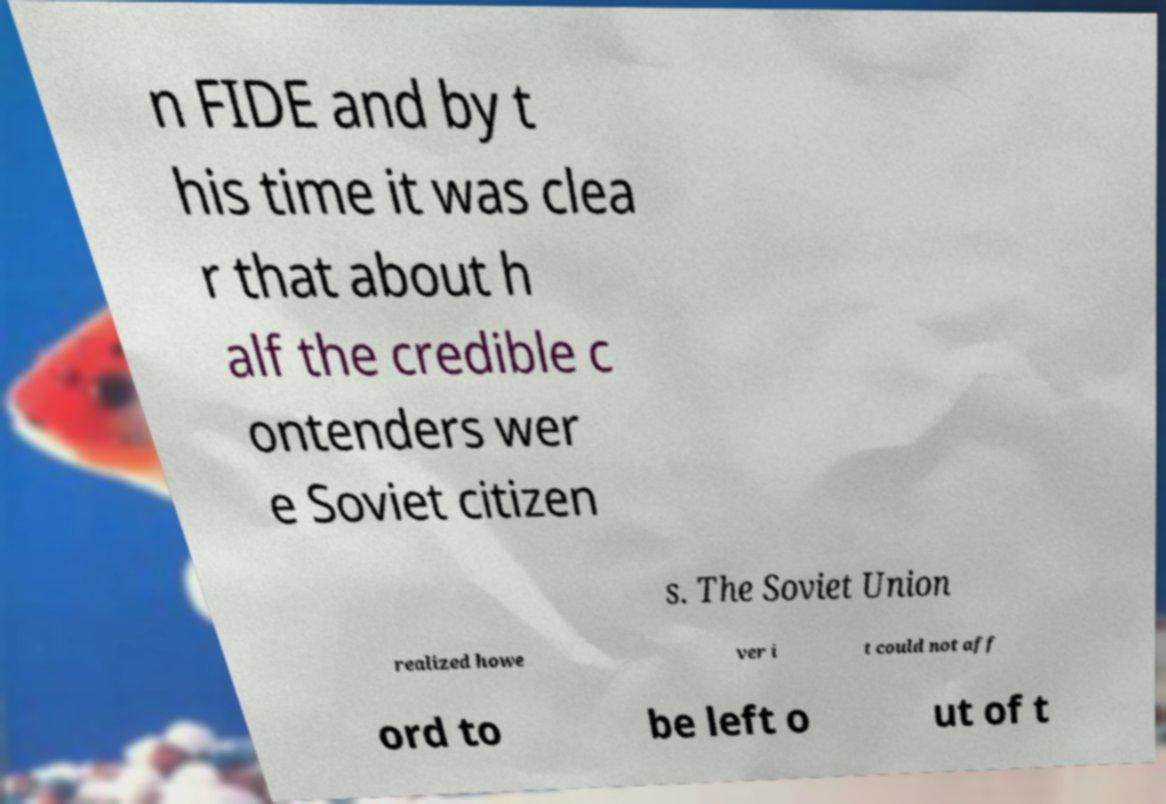There's text embedded in this image that I need extracted. Can you transcribe it verbatim? n FIDE and by t his time it was clea r that about h alf the credible c ontenders wer e Soviet citizen s. The Soviet Union realized howe ver i t could not aff ord to be left o ut of t 